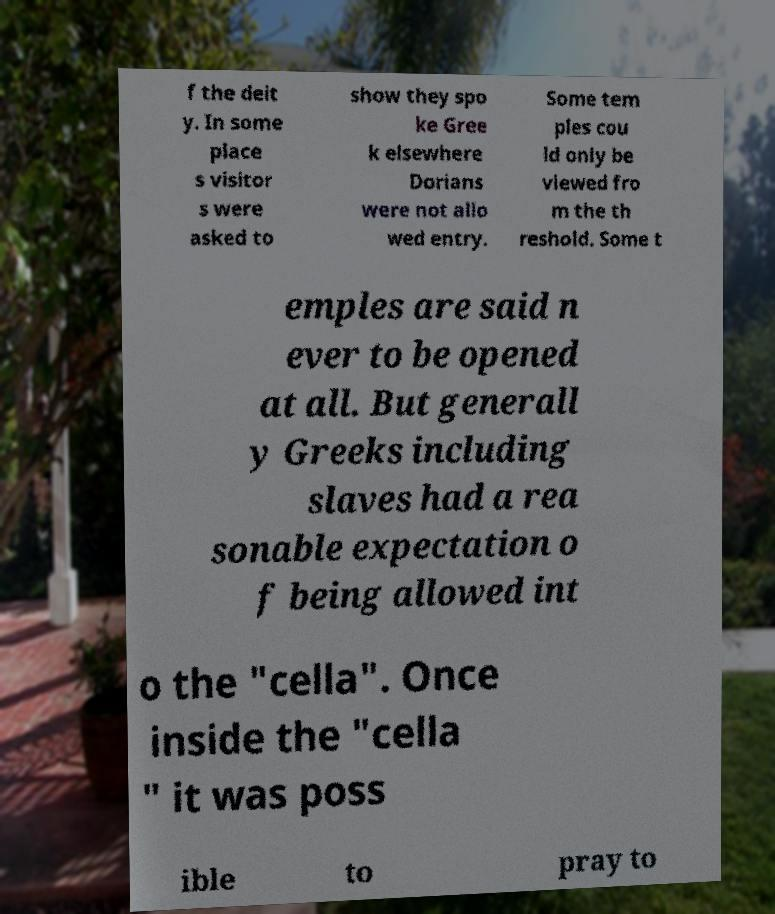What messages or text are displayed in this image? I need them in a readable, typed format. f the deit y. In some place s visitor s were asked to show they spo ke Gree k elsewhere Dorians were not allo wed entry. Some tem ples cou ld only be viewed fro m the th reshold. Some t emples are said n ever to be opened at all. But generall y Greeks including slaves had a rea sonable expectation o f being allowed int o the "cella". Once inside the "cella " it was poss ible to pray to 